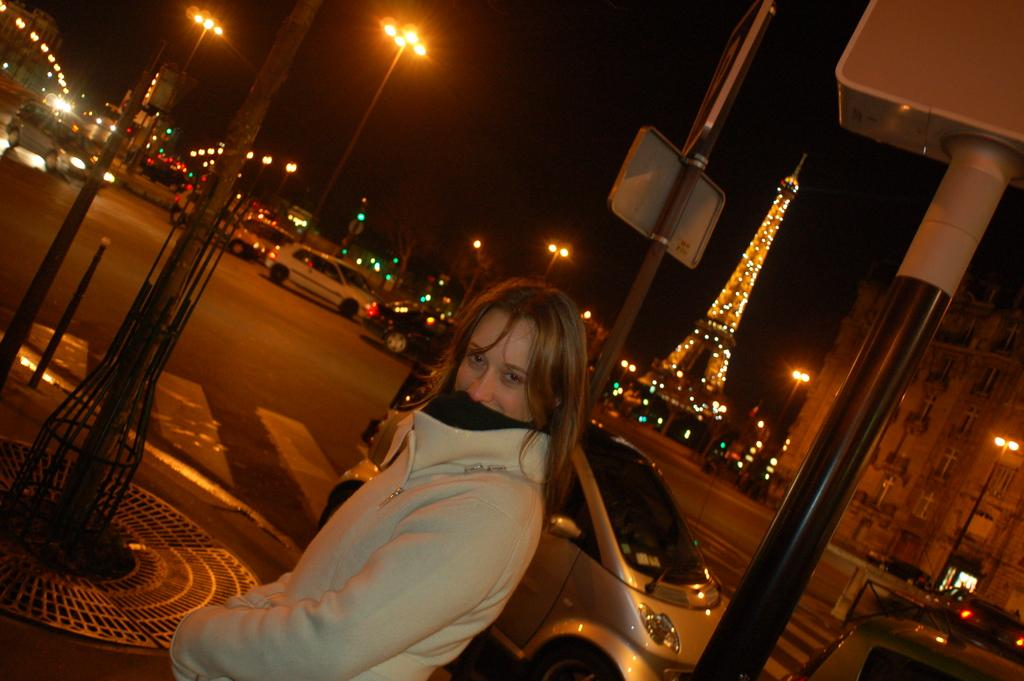Who is the main subject in the image? There is a lady in the image. What structures can be seen in the image? There are light poles, a tower, and buildings in the image. What else is present in the image besides the lady and structures? There are vehicles in the image. How would you describe the background of the image? The background of the image is dark. What type of bath can be seen in the image? There is no bath present in the image. What idea does the lady have in the image? The image does not provide any information about the lady's ideas or thoughts. 